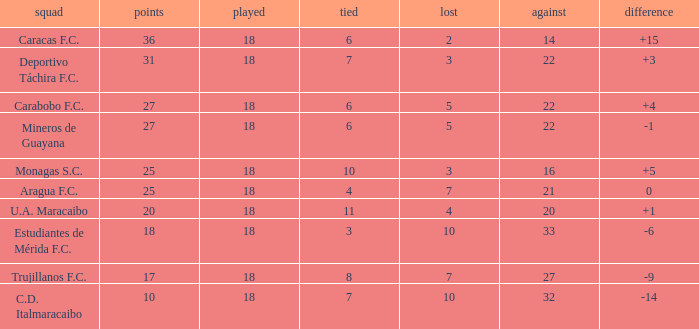What is the lowest number of points of any team with less than 6 draws and less than 18 matches played? None. 